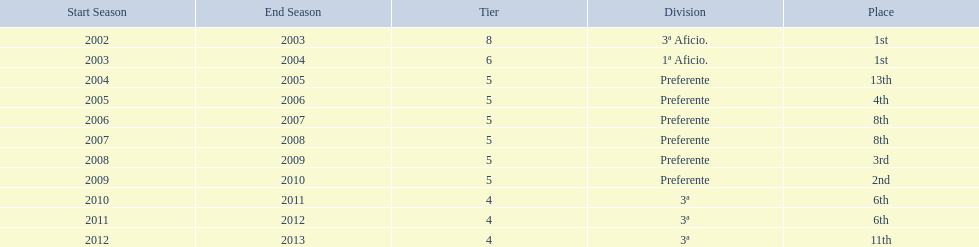Which seasons were played in tier four? 2010/11, 2011/12, 2012/13. Of these seasons, which resulted in 6th place? 2010/11, 2011/12. Which of the remaining happened last? 2011/12. 